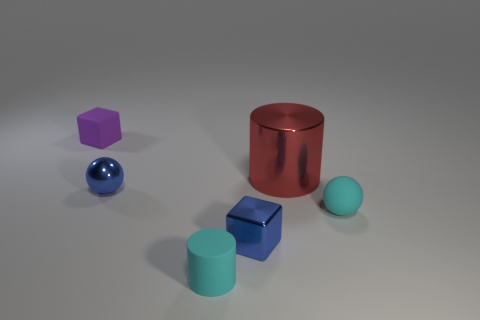What number of matte things are to the left of the cyan rubber ball and on the right side of the small purple rubber cube?
Offer a very short reply. 1. Are the red cylinder and the tiny blue block made of the same material?
Provide a succinct answer. Yes. The tiny blue object that is left of the small cyan matte object that is on the left side of the metal cylinder behind the tiny cyan rubber cylinder is what shape?
Offer a very short reply. Sphere. There is a object that is behind the blue metal ball and on the right side of the blue sphere; what material is it?
Your response must be concise. Metal. There is a ball that is in front of the blue shiny thing behind the cyan object on the right side of the red object; what is its color?
Make the answer very short. Cyan. What number of red objects are either big cylinders or tiny cylinders?
Offer a very short reply. 1. How many other things are there of the same size as the purple block?
Give a very brief answer. 4. How many small rubber objects are there?
Your answer should be very brief. 3. Is the block that is in front of the tiny purple rubber block made of the same material as the cylinder that is right of the tiny blue cube?
Your response must be concise. Yes. What material is the purple object?
Ensure brevity in your answer.  Rubber. 